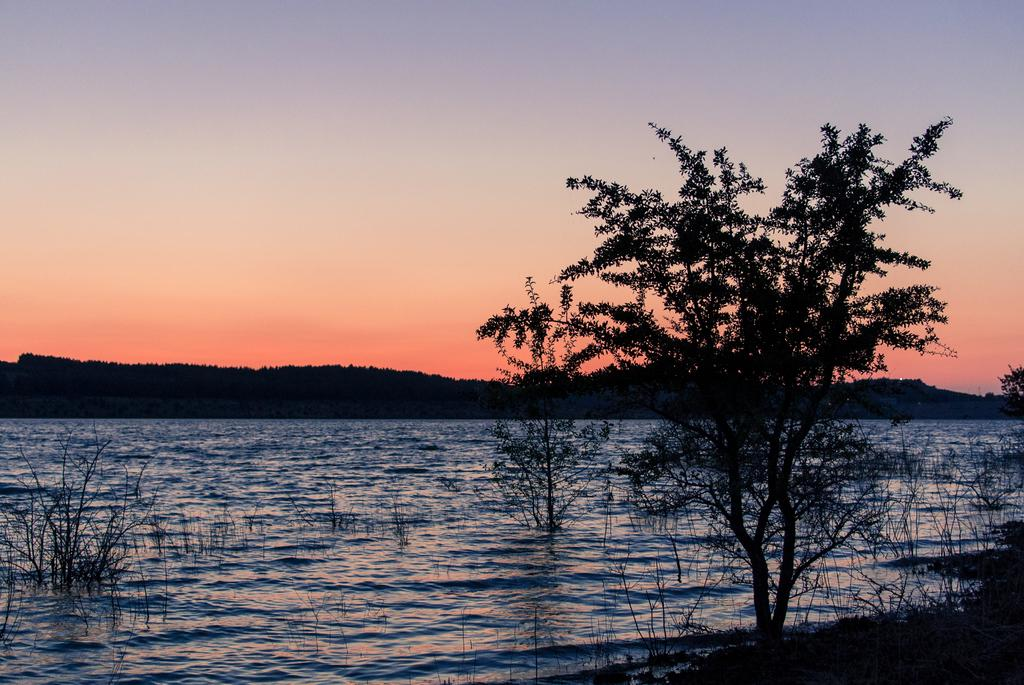What type of natural body of water is present in the image? There is a lake in the image. What can be seen on the right side of the image? There are trees and plants on the right side of the image. What is visible in the background of the image? There is a mountain visible in the background of the image. What is visible at the top of the image? The sky is visible at the top of the image. How many shoes can be seen floating in the lake in the image? There are no shoes present in the image; it features a lake with trees, plants, a mountain, and the sky. Are there any ants visible on the trees in the image? There is no mention of ants in the image, and they are not visible in the provided facts. 